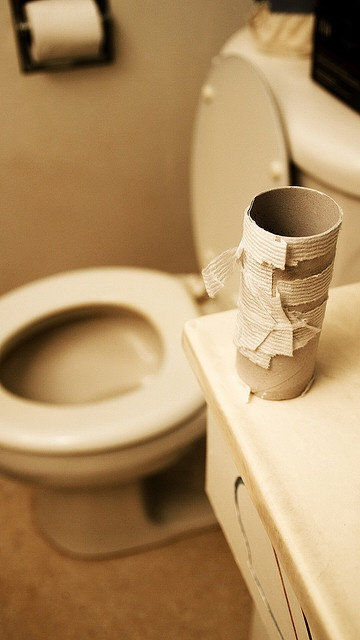Describe the objects in this image and their specific colors. I can see a toilet in tan and olive tones in this image. 